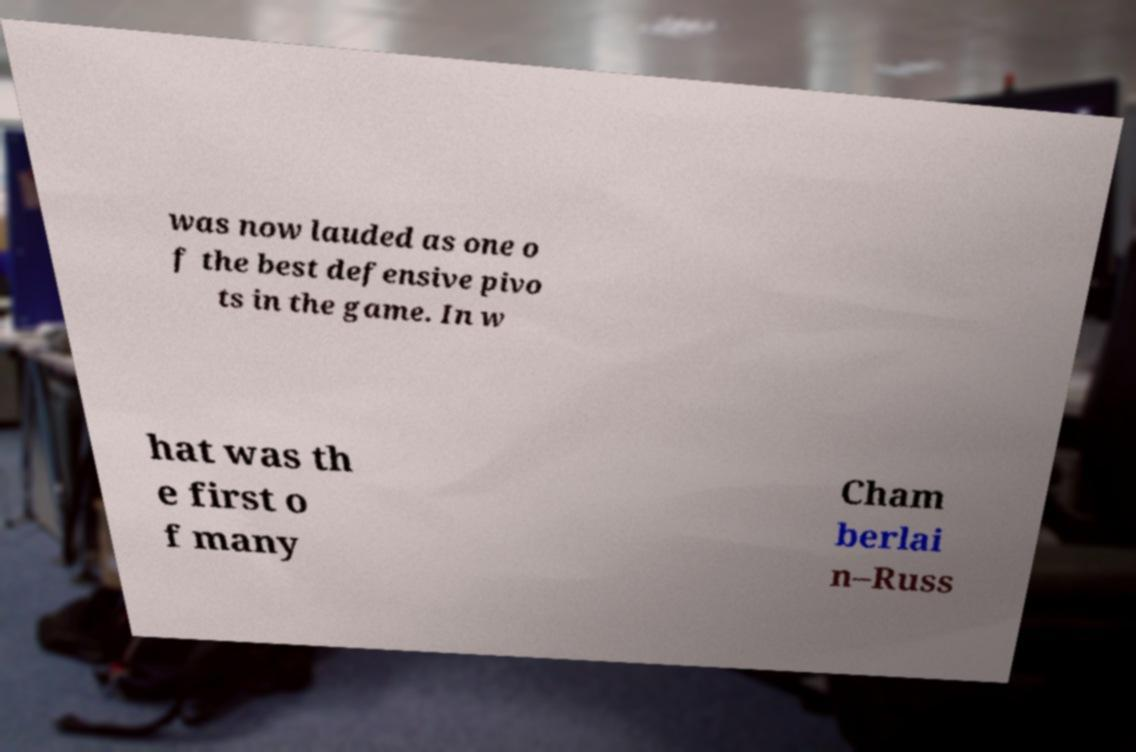What messages or text are displayed in this image? I need them in a readable, typed format. was now lauded as one o f the best defensive pivo ts in the game. In w hat was th e first o f many Cham berlai n–Russ 